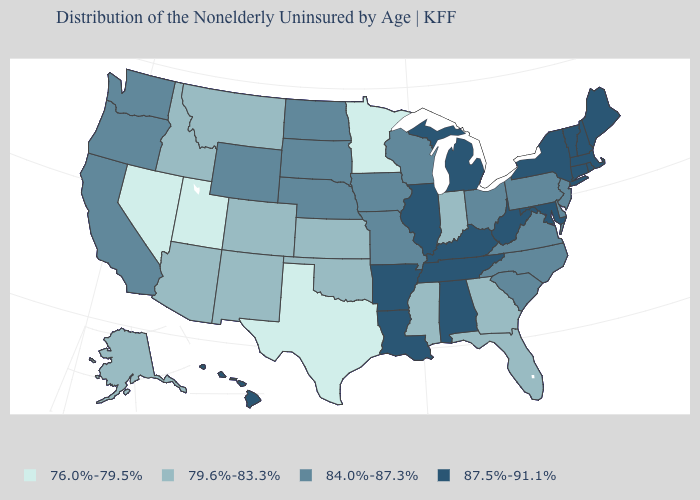Does Indiana have the lowest value in the MidWest?
Concise answer only. No. What is the lowest value in the USA?
Give a very brief answer. 76.0%-79.5%. What is the value of California?
Give a very brief answer. 84.0%-87.3%. Name the states that have a value in the range 76.0%-79.5%?
Keep it brief. Minnesota, Nevada, Texas, Utah. What is the value of New Jersey?
Answer briefly. 84.0%-87.3%. Name the states that have a value in the range 79.6%-83.3%?
Give a very brief answer. Alaska, Arizona, Colorado, Florida, Georgia, Idaho, Indiana, Kansas, Mississippi, Montana, New Mexico, Oklahoma. Does Delaware have a higher value than Utah?
Quick response, please. Yes. Name the states that have a value in the range 79.6%-83.3%?
Short answer required. Alaska, Arizona, Colorado, Florida, Georgia, Idaho, Indiana, Kansas, Mississippi, Montana, New Mexico, Oklahoma. What is the value of Louisiana?
Keep it brief. 87.5%-91.1%. What is the value of New Jersey?
Give a very brief answer. 84.0%-87.3%. Does the map have missing data?
Keep it brief. No. Name the states that have a value in the range 79.6%-83.3%?
Write a very short answer. Alaska, Arizona, Colorado, Florida, Georgia, Idaho, Indiana, Kansas, Mississippi, Montana, New Mexico, Oklahoma. What is the value of South Dakota?
Keep it brief. 84.0%-87.3%. Does Texas have the same value as Nevada?
Be succinct. Yes. Does Oklahoma have the same value as Kansas?
Quick response, please. Yes. 